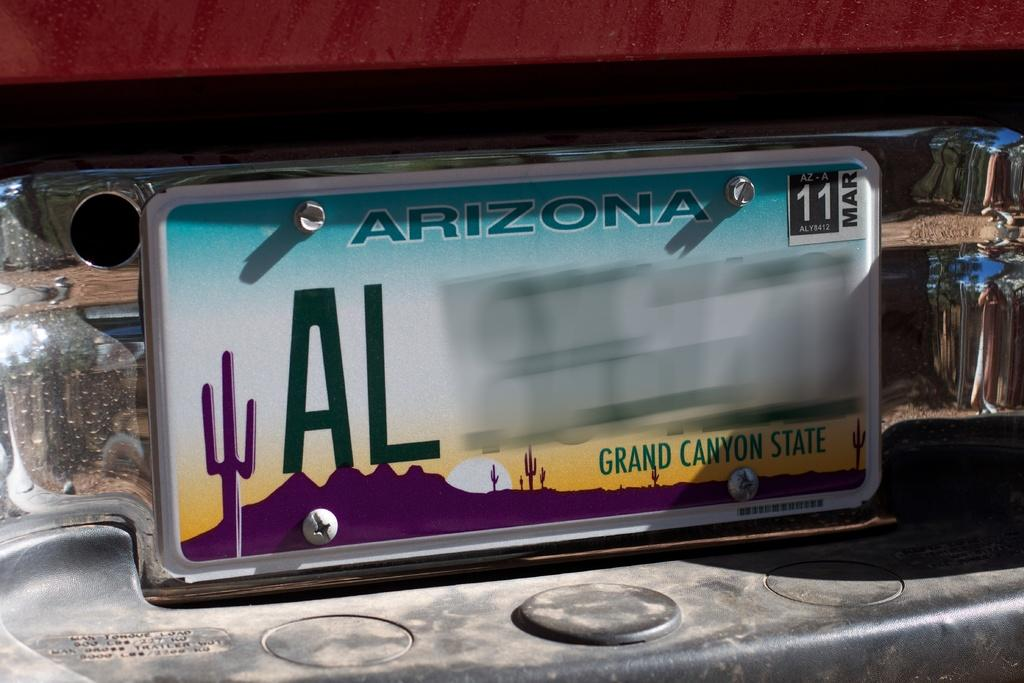<image>
Offer a succinct explanation of the picture presented. A close up view of an Arizona license plate that begins with the letters "AL" 